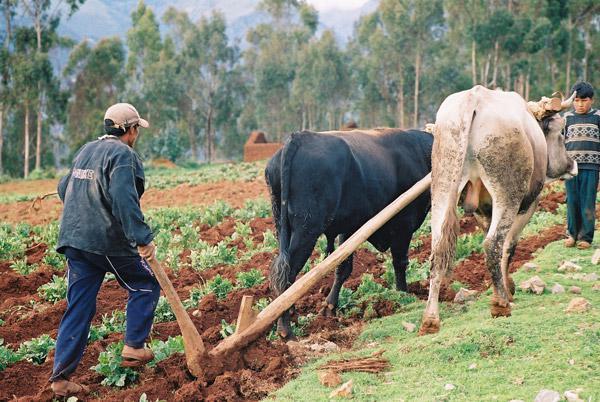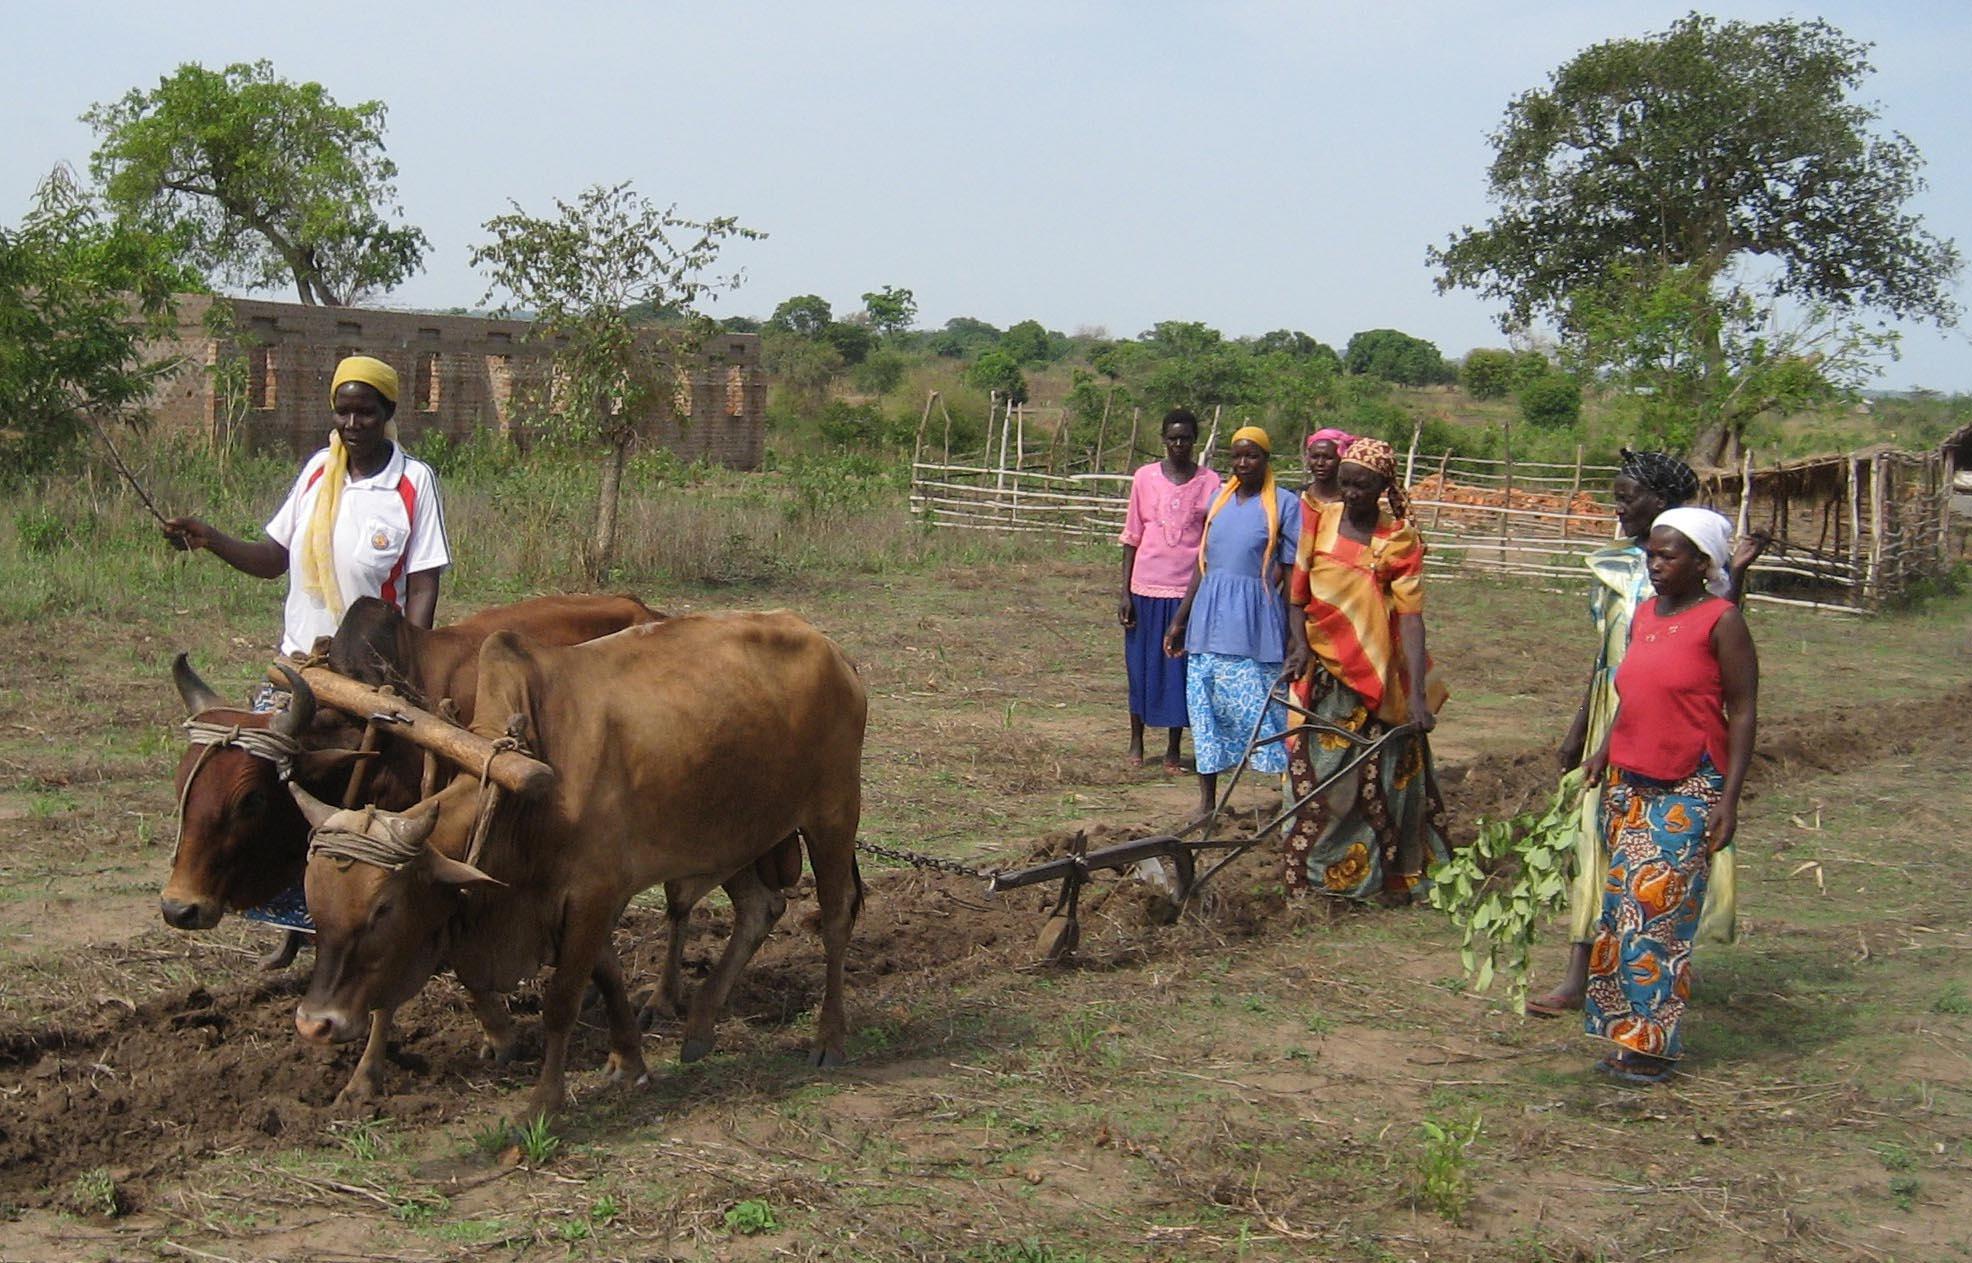The first image is the image on the left, the second image is the image on the right. Analyze the images presented: Is the assertion "Both images show cows plowing a field." valid? Answer yes or no. Yes. 